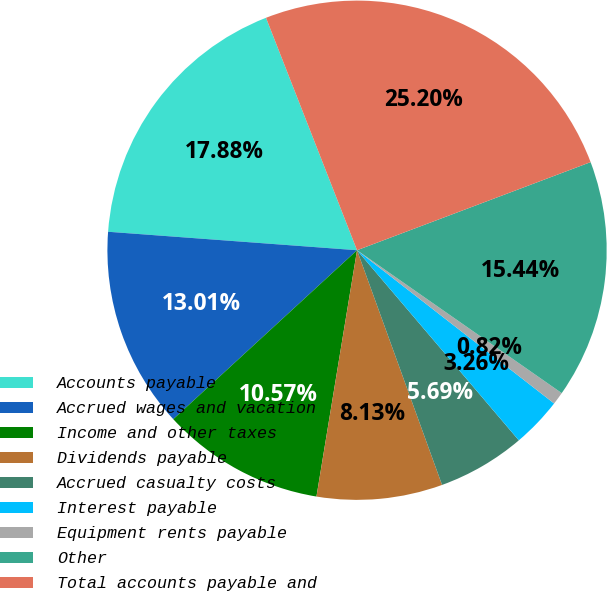Convert chart to OTSL. <chart><loc_0><loc_0><loc_500><loc_500><pie_chart><fcel>Accounts payable<fcel>Accrued wages and vacation<fcel>Income and other taxes<fcel>Dividends payable<fcel>Accrued casualty costs<fcel>Interest payable<fcel>Equipment rents payable<fcel>Other<fcel>Total accounts payable and<nl><fcel>17.88%<fcel>13.01%<fcel>10.57%<fcel>8.13%<fcel>5.69%<fcel>3.26%<fcel>0.82%<fcel>15.44%<fcel>25.2%<nl></chart> 